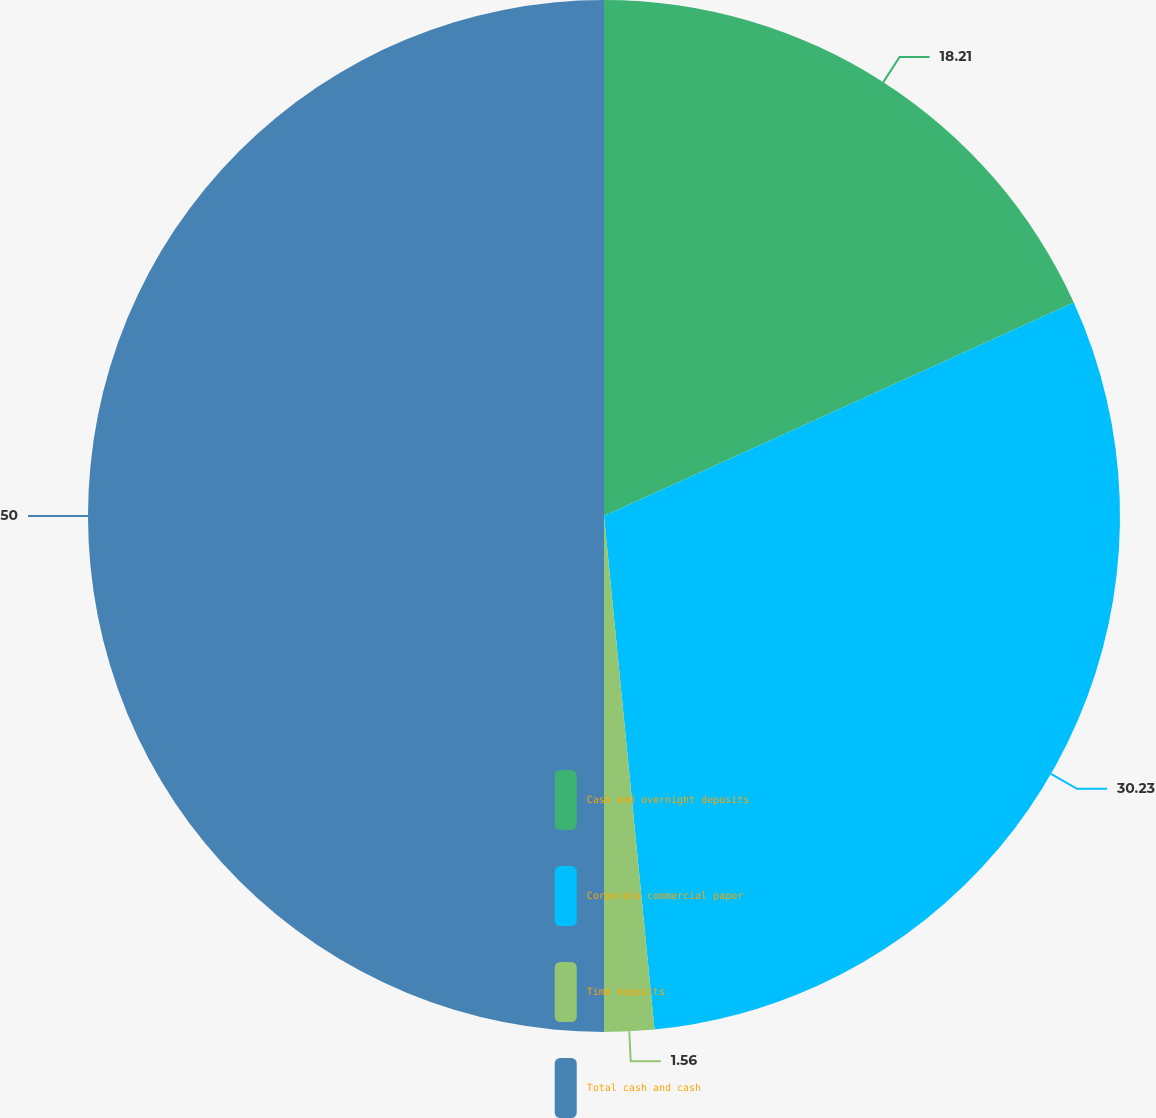<chart> <loc_0><loc_0><loc_500><loc_500><pie_chart><fcel>Cash and overnight deposits<fcel>Corporate commercial paper<fcel>Time deposits<fcel>Total cash and cash<nl><fcel>18.21%<fcel>30.23%<fcel>1.56%<fcel>50.0%<nl></chart> 